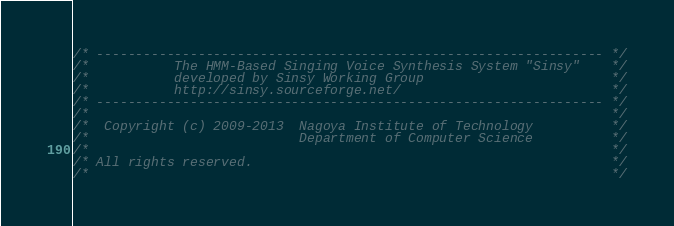Convert code to text. <code><loc_0><loc_0><loc_500><loc_500><_C_>/* ----------------------------------------------------------------- */
/*           The HMM-Based Singing Voice Synthesis System "Sinsy"    */
/*           developed by Sinsy Working Group                        */
/*           http://sinsy.sourceforge.net/                           */
/* ----------------------------------------------------------------- */
/*                                                                   */
/*  Copyright (c) 2009-2013  Nagoya Institute of Technology          */
/*                           Department of Computer Science          */
/*                                                                   */
/* All rights reserved.                                              */
/*                                                                   */</code> 